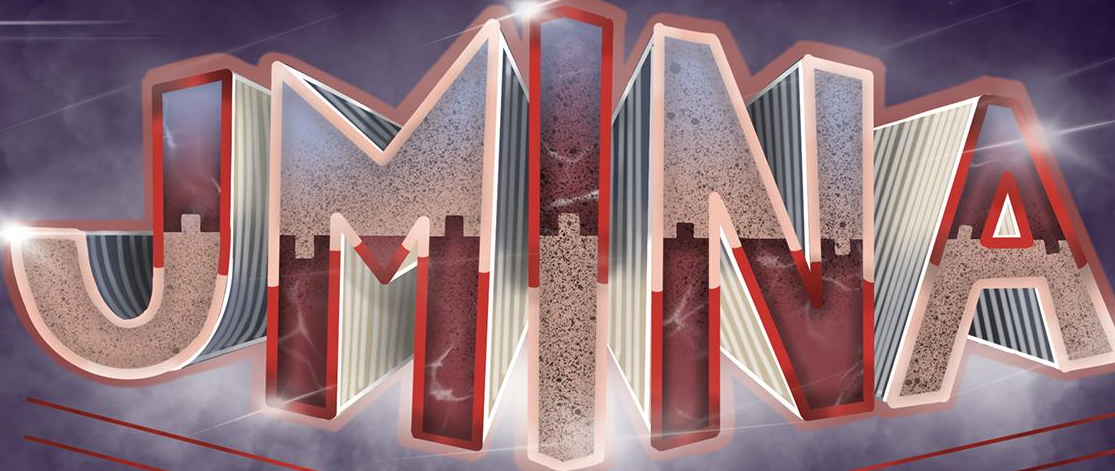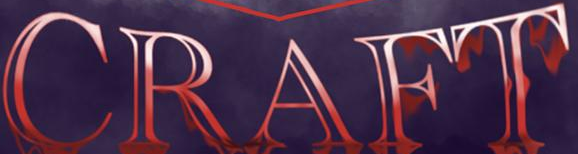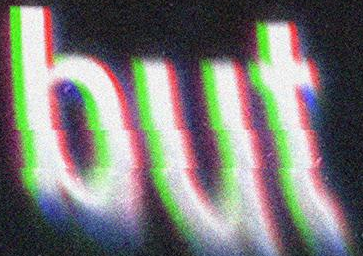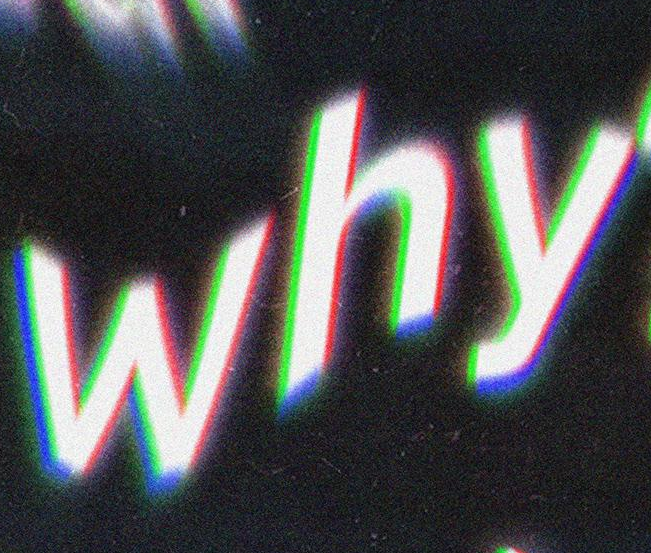What words are shown in these images in order, separated by a semicolon? JMINA; CRAFT; but; why 